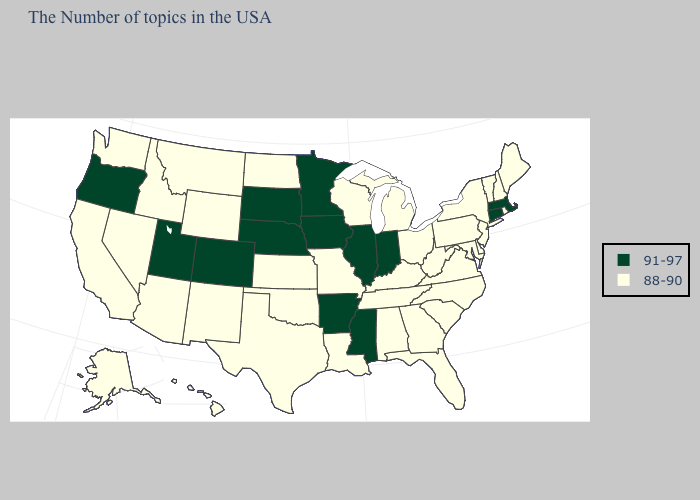What is the value of Nevada?
Answer briefly. 88-90. Name the states that have a value in the range 91-97?
Write a very short answer. Massachusetts, Connecticut, Indiana, Illinois, Mississippi, Arkansas, Minnesota, Iowa, Nebraska, South Dakota, Colorado, Utah, Oregon. What is the value of Delaware?
Short answer required. 88-90. Does Kansas have the highest value in the USA?
Short answer required. No. What is the value of Washington?
Answer briefly. 88-90. Which states hav the highest value in the South?
Quick response, please. Mississippi, Arkansas. Name the states that have a value in the range 88-90?
Short answer required. Maine, Rhode Island, New Hampshire, Vermont, New York, New Jersey, Delaware, Maryland, Pennsylvania, Virginia, North Carolina, South Carolina, West Virginia, Ohio, Florida, Georgia, Michigan, Kentucky, Alabama, Tennessee, Wisconsin, Louisiana, Missouri, Kansas, Oklahoma, Texas, North Dakota, Wyoming, New Mexico, Montana, Arizona, Idaho, Nevada, California, Washington, Alaska, Hawaii. What is the value of Illinois?
Write a very short answer. 91-97. Does Oregon have the highest value in the USA?
Write a very short answer. Yes. What is the value of Nevada?
Write a very short answer. 88-90. Name the states that have a value in the range 88-90?
Quick response, please. Maine, Rhode Island, New Hampshire, Vermont, New York, New Jersey, Delaware, Maryland, Pennsylvania, Virginia, North Carolina, South Carolina, West Virginia, Ohio, Florida, Georgia, Michigan, Kentucky, Alabama, Tennessee, Wisconsin, Louisiana, Missouri, Kansas, Oklahoma, Texas, North Dakota, Wyoming, New Mexico, Montana, Arizona, Idaho, Nevada, California, Washington, Alaska, Hawaii. How many symbols are there in the legend?
Quick response, please. 2. Name the states that have a value in the range 88-90?
Give a very brief answer. Maine, Rhode Island, New Hampshire, Vermont, New York, New Jersey, Delaware, Maryland, Pennsylvania, Virginia, North Carolina, South Carolina, West Virginia, Ohio, Florida, Georgia, Michigan, Kentucky, Alabama, Tennessee, Wisconsin, Louisiana, Missouri, Kansas, Oklahoma, Texas, North Dakota, Wyoming, New Mexico, Montana, Arizona, Idaho, Nevada, California, Washington, Alaska, Hawaii. What is the value of Iowa?
Quick response, please. 91-97. Among the states that border Louisiana , does Texas have the highest value?
Give a very brief answer. No. 